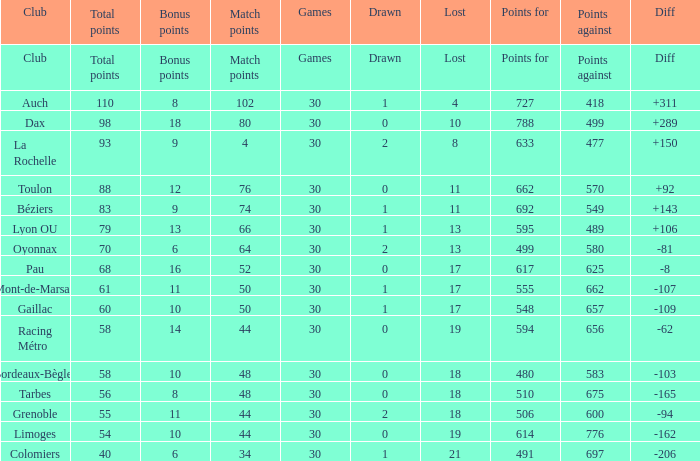What is the number of games for a club that has a value of 595 for points for? 30.0. 